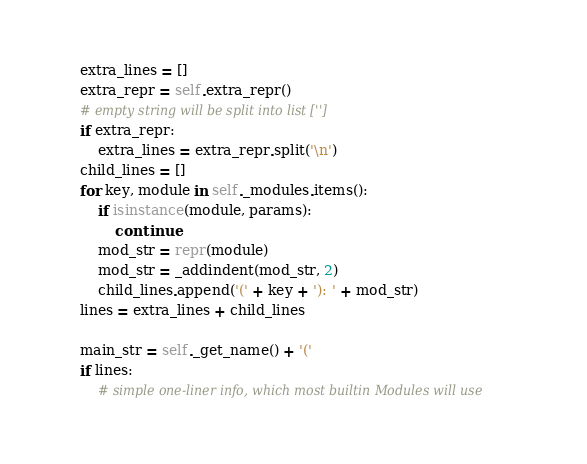Convert code to text. <code><loc_0><loc_0><loc_500><loc_500><_Python_>    extra_lines = []
    extra_repr = self.extra_repr()
    # empty string will be split into list ['']
    if extra_repr:
        extra_lines = extra_repr.split('\n')
    child_lines = []
    for key, module in self._modules.items():
        if isinstance(module, params):
            continue
        mod_str = repr(module)
        mod_str = _addindent(mod_str, 2)
        child_lines.append('(' + key + '): ' + mod_str)
    lines = extra_lines + child_lines

    main_str = self._get_name() + '('
    if lines:
        # simple one-liner info, which most builtin Modules will use</code> 